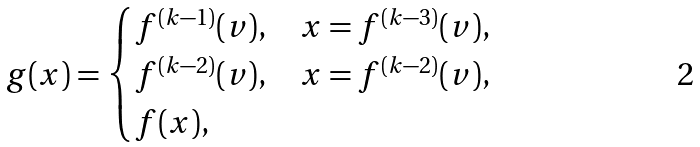<formula> <loc_0><loc_0><loc_500><loc_500>g ( x ) = \begin{cases} f ^ { ( k - 1 ) } ( v ) , & x = f ^ { ( k - 3 ) } ( v ) , \\ f ^ { ( k - 2 ) } ( v ) , & x = f ^ { ( k - 2 ) } ( v ) , \\ f ( x ) , & \end{cases}</formula> 